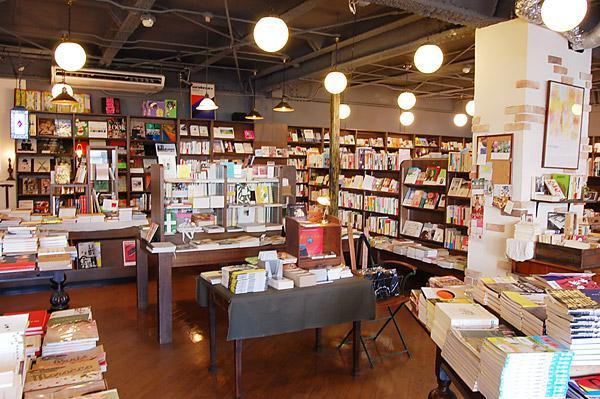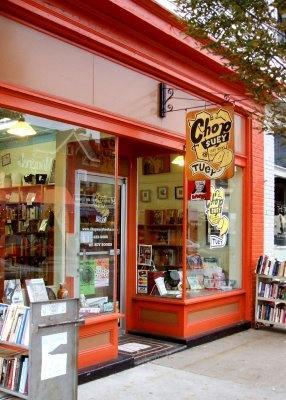The first image is the image on the left, the second image is the image on the right. Given the left and right images, does the statement "In at least one image there are two bright orange ball lamps that are on hanging from the ceiling  of either side of an archway" hold true? Answer yes or no. No. The first image is the image on the left, the second image is the image on the right. Considering the images on both sides, is "At least one image shows an orange ball hanging over a display case and in front of an arch in a room with no people in it." valid? Answer yes or no. No. 